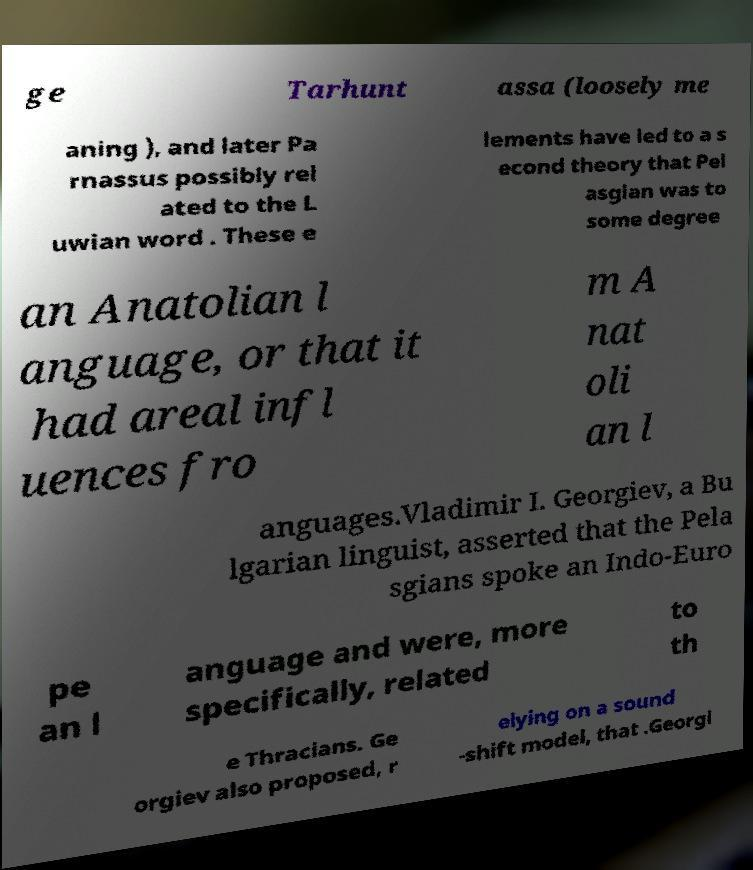Can you read and provide the text displayed in the image?This photo seems to have some interesting text. Can you extract and type it out for me? ge Tarhunt assa (loosely me aning ), and later Pa rnassus possibly rel ated to the L uwian word . These e lements have led to a s econd theory that Pel asgian was to some degree an Anatolian l anguage, or that it had areal infl uences fro m A nat oli an l anguages.Vladimir I. Georgiev, a Bu lgarian linguist, asserted that the Pela sgians spoke an Indo-Euro pe an l anguage and were, more specifically, related to th e Thracians. Ge orgiev also proposed, r elying on a sound -shift model, that .Georgi 